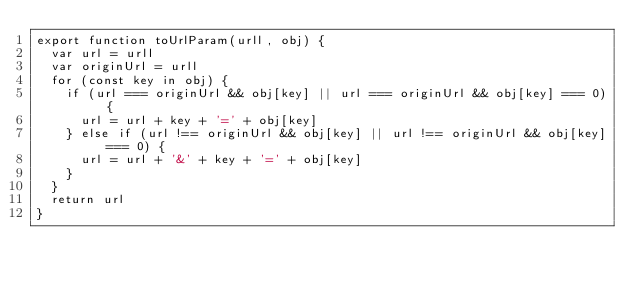<code> <loc_0><loc_0><loc_500><loc_500><_JavaScript_>export function toUrlParam(urll, obj) {
  var url = urll
  var originUrl = urll
  for (const key in obj) {
    if (url === originUrl && obj[key] || url === originUrl && obj[key] === 0) {
      url = url + key + '=' + obj[key]
    } else if (url !== originUrl && obj[key] || url !== originUrl && obj[key] === 0) {
      url = url + '&' + key + '=' + obj[key]
    }
  }
  return url
}
</code> 